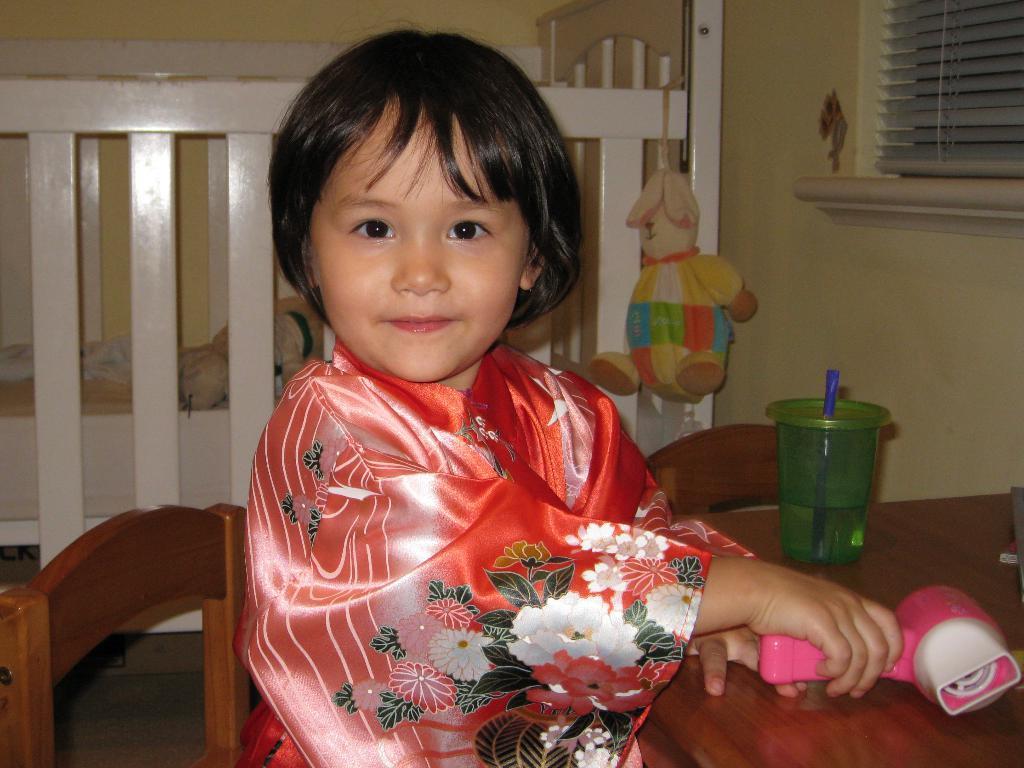How would you summarize this image in a sentence or two? In this image i can see a child sitting on a chair in front of a table, on the table i can see a glass. in the background i can see a wall, a window blind and a children bed. 